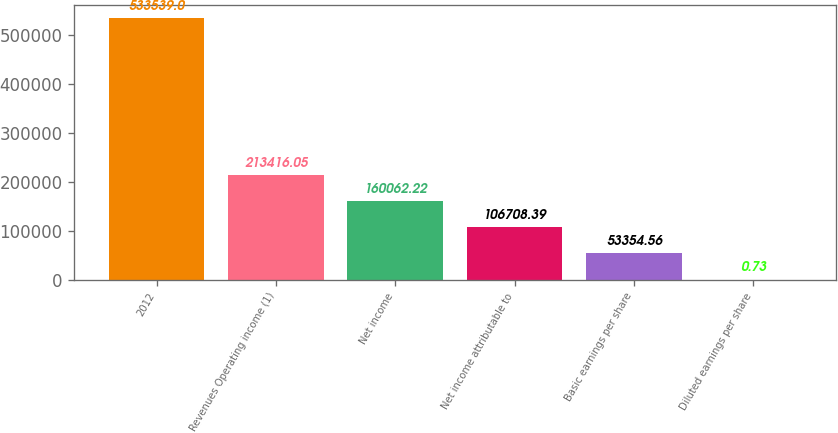Convert chart to OTSL. <chart><loc_0><loc_0><loc_500><loc_500><bar_chart><fcel>2012<fcel>Revenues Operating income (1)<fcel>Net income<fcel>Net income attributable to<fcel>Basic earnings per share<fcel>Diluted earnings per share<nl><fcel>533539<fcel>213416<fcel>160062<fcel>106708<fcel>53354.6<fcel>0.73<nl></chart> 